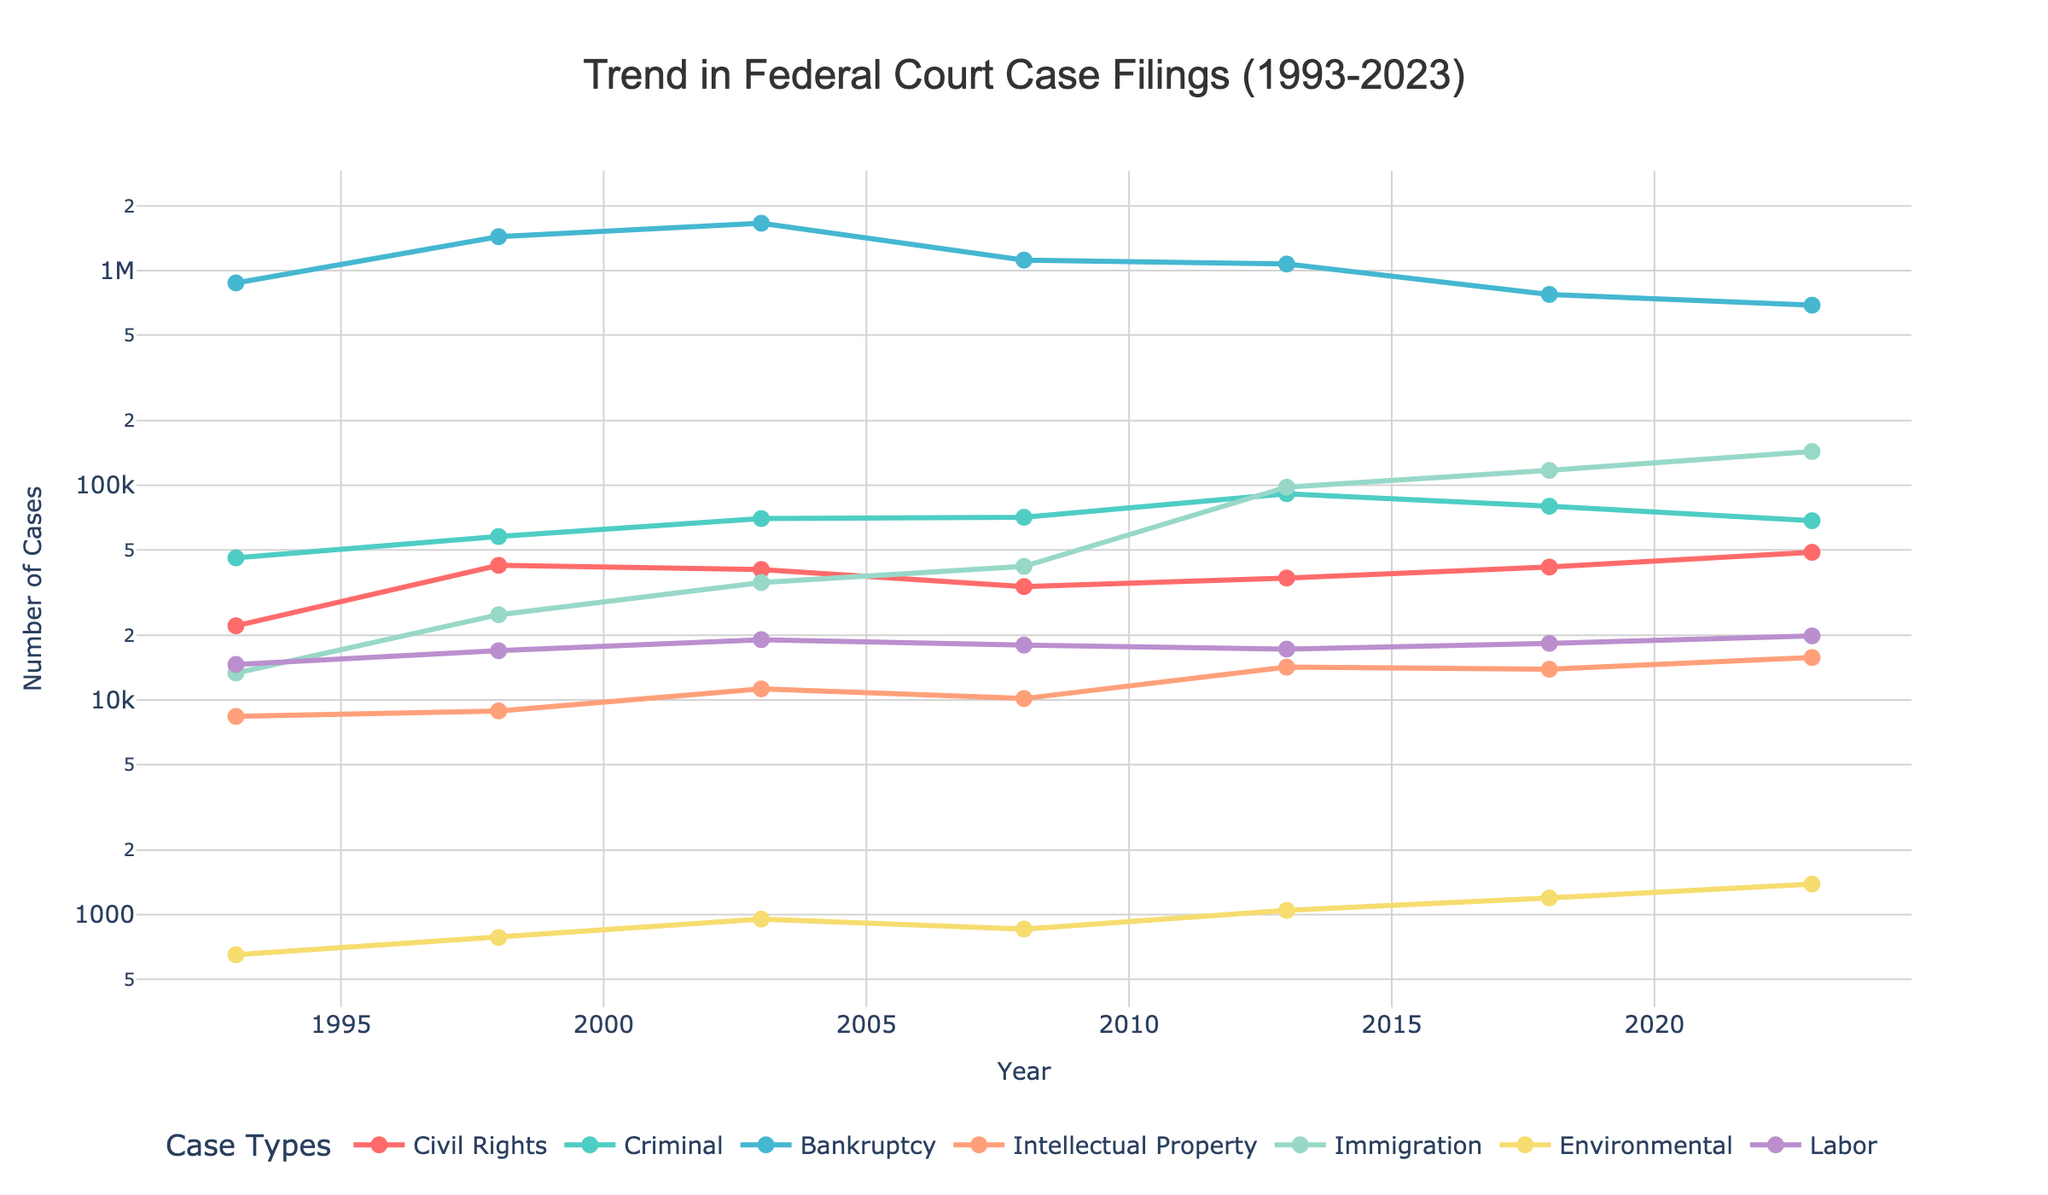How many more Civil Rights cases were filed in 2023 compared to 1993? In 1993, there were 22,150 Civil Rights cases filed. In 2023, the number rose to 48,692. The difference is 48,692 - 22,150.
Answer: 26,542 Which year had the highest number of Criminal cases filed, and what was that number? From the figure, the highest number of Criminal cases were filed in 2013 with 91,266 cases.
Answer: 2013, 91,266 How did the number of Bankruptcy cases change from 2008 to 2018? There were 1,117,771 Bankruptcy cases in 2008 and 773,375 in 2018. The change is 1,117,771 - 773,375.
Answer: Decreased by 344,396 What is the trend in the number of Immigration cases from 1993 to 2023? The number of Immigration cases shows a generally increasing trend. It starts at 13,348 in 1993 and rises to 143,568 in 2023.
Answer: Increasing trend Which type of cases had the highest filing number in 1998 and what was the number? In 1998, Bankruptcy cases had the highest number of filings, amounting to 1,436,964.
Answer: Bankruptcy, 1,436,964 By how much did the number of Labor cases increase from 1993 to 2023? The number of Labor cases in 1993 was 14,635 and it increased to 19,876 in 2023. The increase is 19,876 - 14,635.
Answer: 5,241 Was there any type of case that showed a decreasing trend between 2013 and 2023? If so, which one? Comparing the data, the number of Criminal cases decreased from 91,266 in 2013 to 68,341 in 2023.
Answer: Criminal Which case type had the smallest filing number across the entire timeline and what was that number? The smallest filing number among all the types was for Environmental cases in 1993, which was 651.
Answer: Environmental, 651 What visual differences can be observed for the trend in Bankruptcy cases compared to Intellectual Property cases? The Bankruptcy cases trend shows much higher values throughout the years and significant fluctuations, while Intellectual Property cases have lower numbers and a steadier trend.
Answer: Fluctuating high in Bankruptcy, steady low in Intellectual Property 